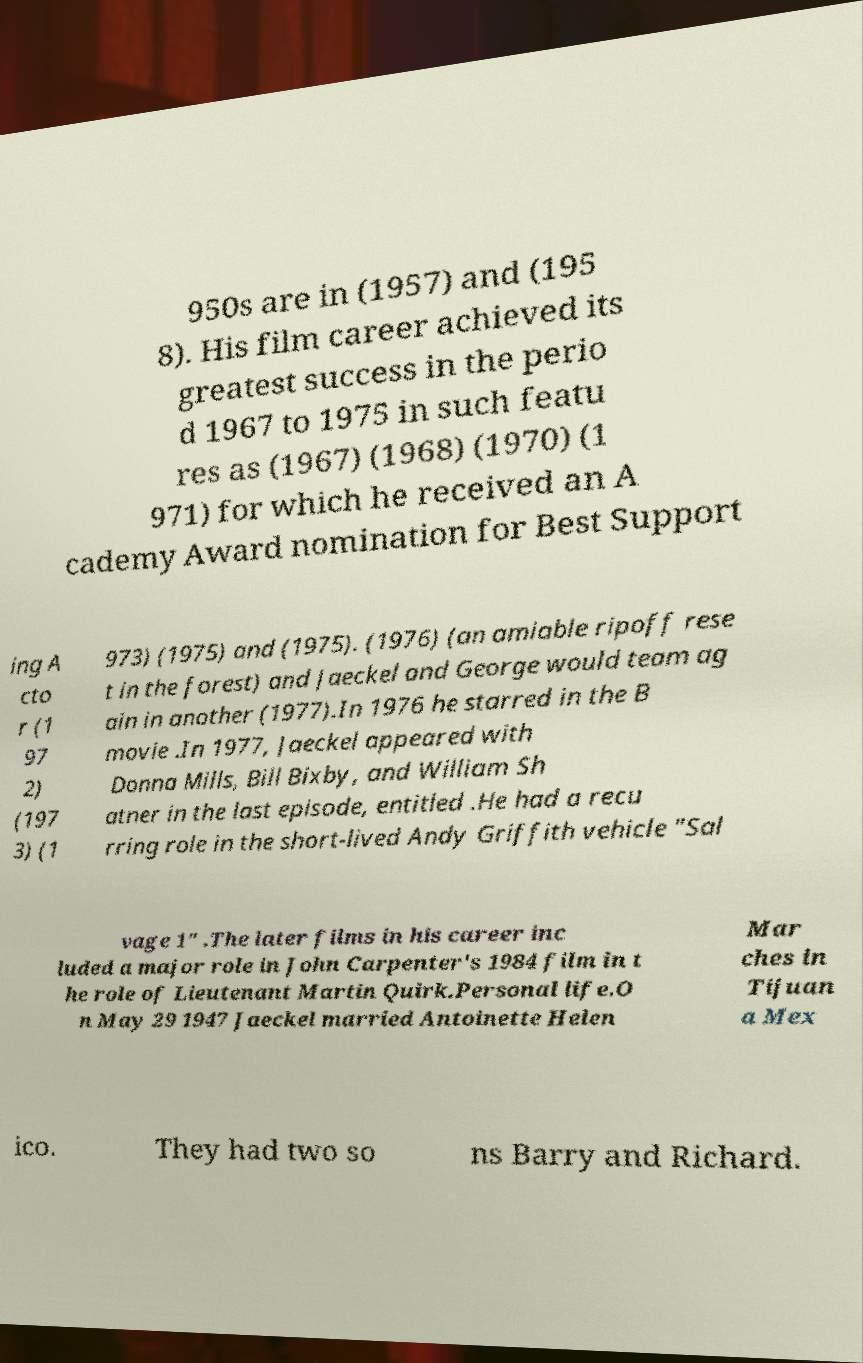Please identify and transcribe the text found in this image. 950s are in (1957) and (195 8). His film career achieved its greatest success in the perio d 1967 to 1975 in such featu res as (1967) (1968) (1970) (1 971) for which he received an A cademy Award nomination for Best Support ing A cto r (1 97 2) (197 3) (1 973) (1975) and (1975). (1976) (an amiable ripoff rese t in the forest) and Jaeckel and George would team ag ain in another (1977).In 1976 he starred in the B movie .In 1977, Jaeckel appeared with Donna Mills, Bill Bixby, and William Sh atner in the last episode, entitled .He had a recu rring role in the short-lived Andy Griffith vehicle "Sal vage 1" .The later films in his career inc luded a major role in John Carpenter's 1984 film in t he role of Lieutenant Martin Quirk.Personal life.O n May 29 1947 Jaeckel married Antoinette Helen Mar ches in Tijuan a Mex ico. They had two so ns Barry and Richard. 